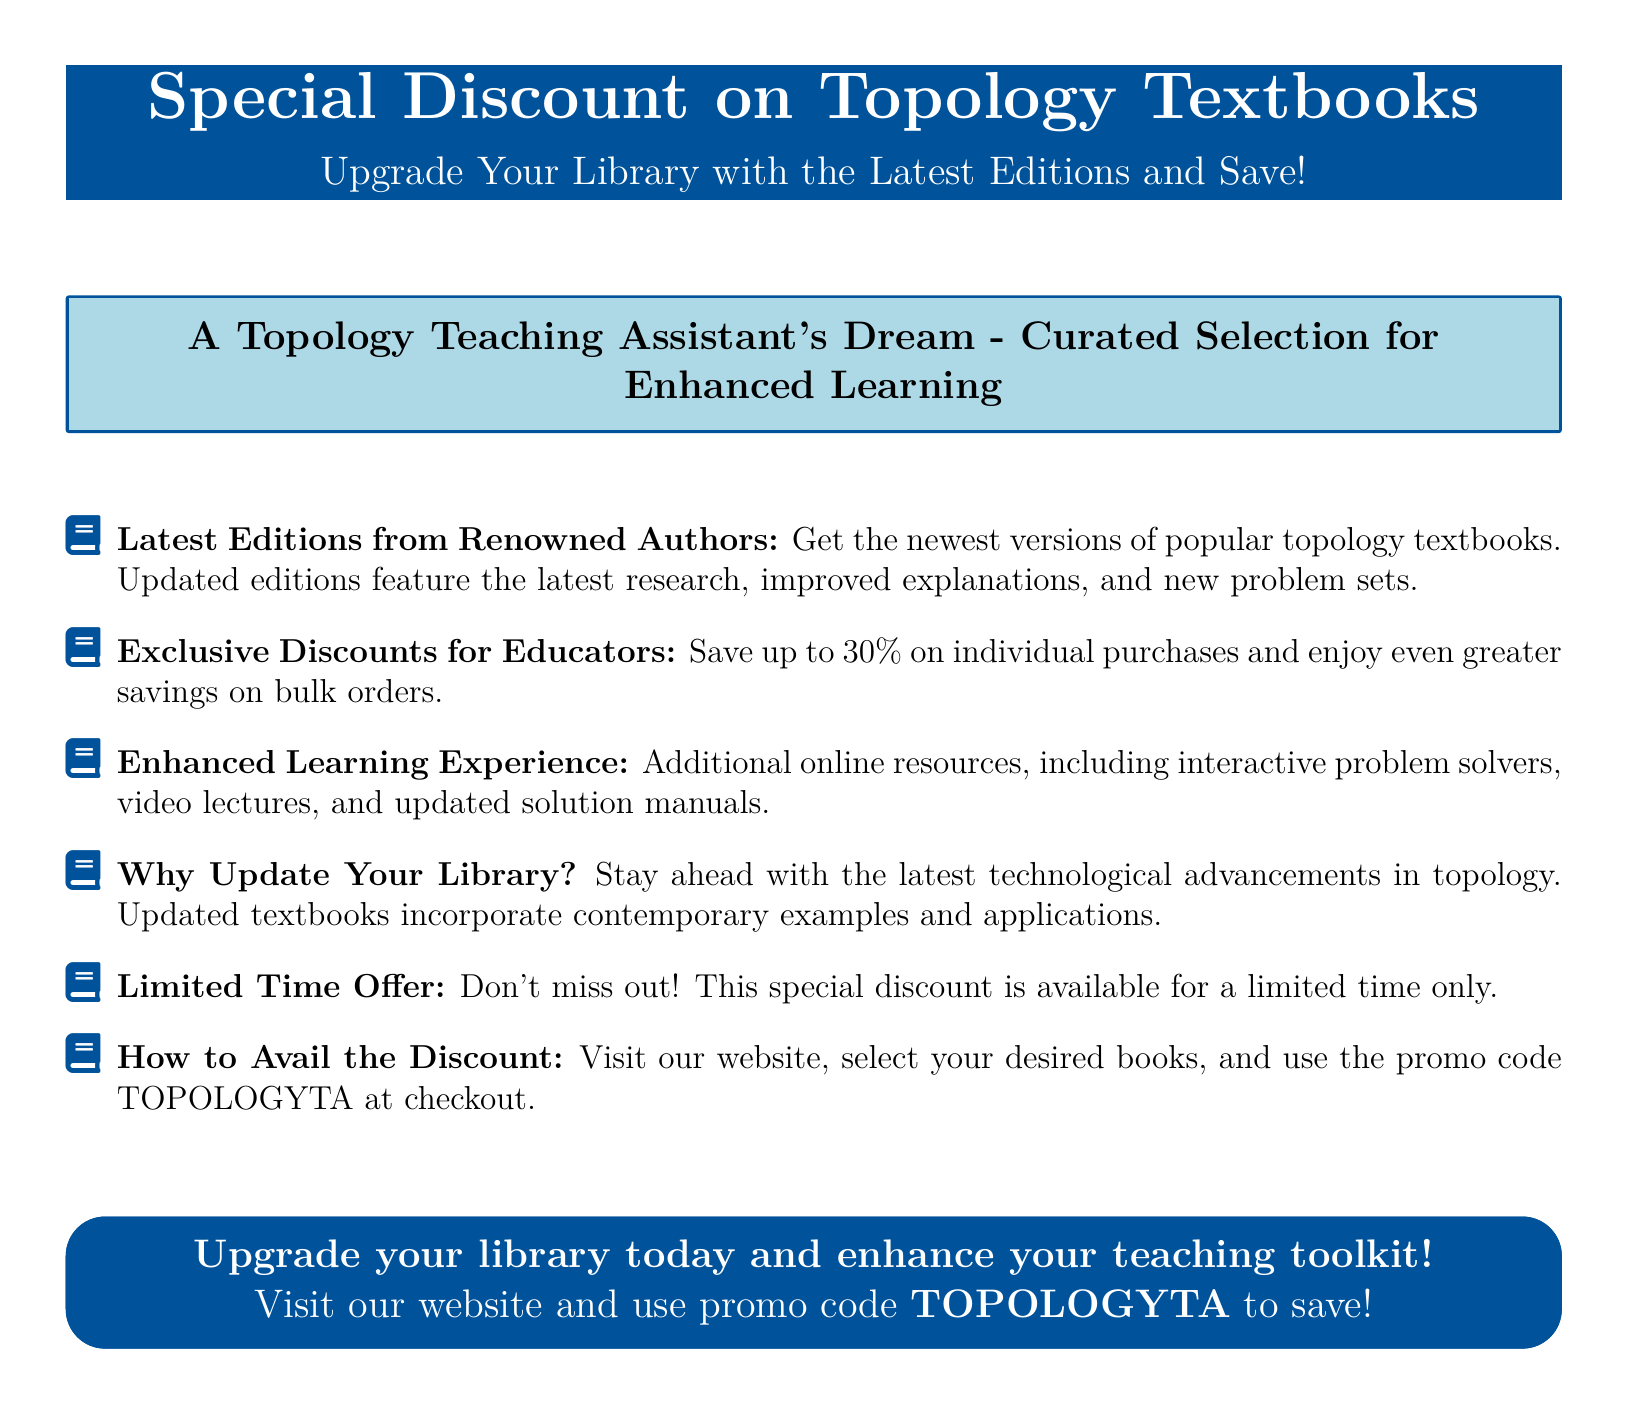What is the maximum discount offered? The document states that the maximum discount is up to 30%.
Answer: 30% What is the promo code for the discount? The document provides the promo code to use at checkout for the discount, which is TOPOLOGYTA.
Answer: TOPOLOGYTA What is emphasized as enhancing the learning experience? The document mentions additional online resources such as interactive problem solvers and video lectures as enhancements.
Answer: Online resources What type of products is the advertisement promoting? The advertisement specifically promotes topology textbooks.
Answer: Topology textbooks What is the purpose of the limited time offer? The document indicates that the limited time offer aims to create urgency and encourage prompt purchases.
Answer: Creating urgency How should one avail of the discount? The document explains that one can visit the website, select books, and enter the promo code during checkout.
Answer: Visit the website What benefit does updating the library provide? The document highlights that updating the library helps stay ahead with the latest technological advancements in topology.
Answer: Staying ahead Who is the target audience for this advertisement? The advertisement aimed at educators, specifically targeting topology teaching assistants and teachers.
Answer: Educators 